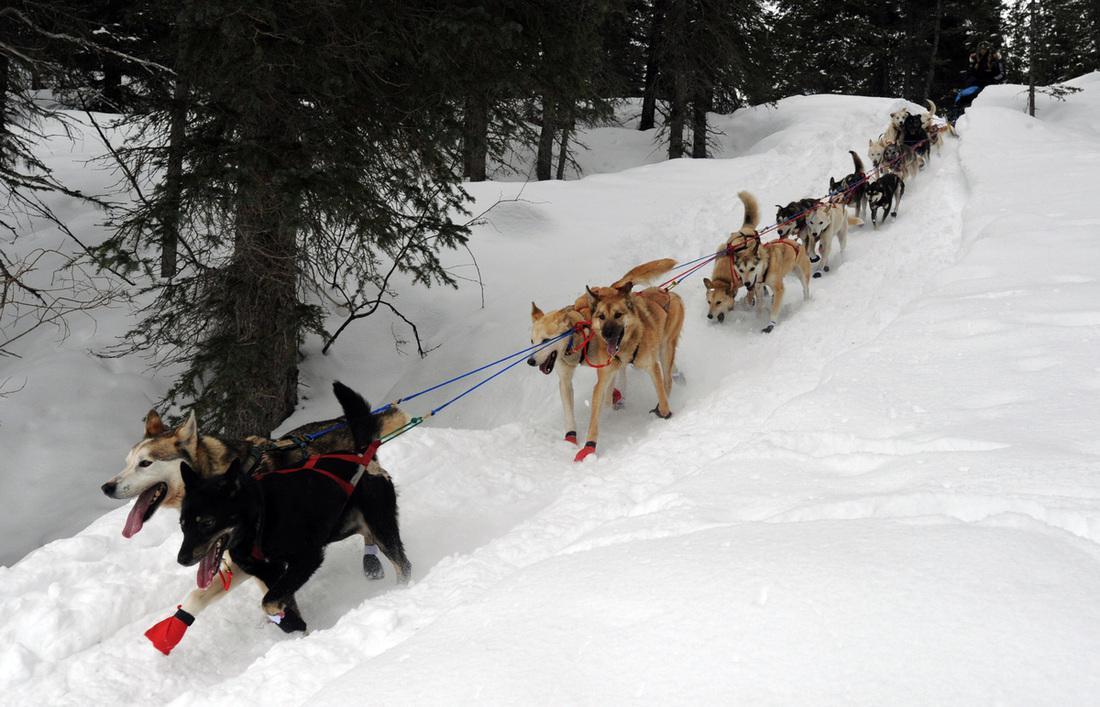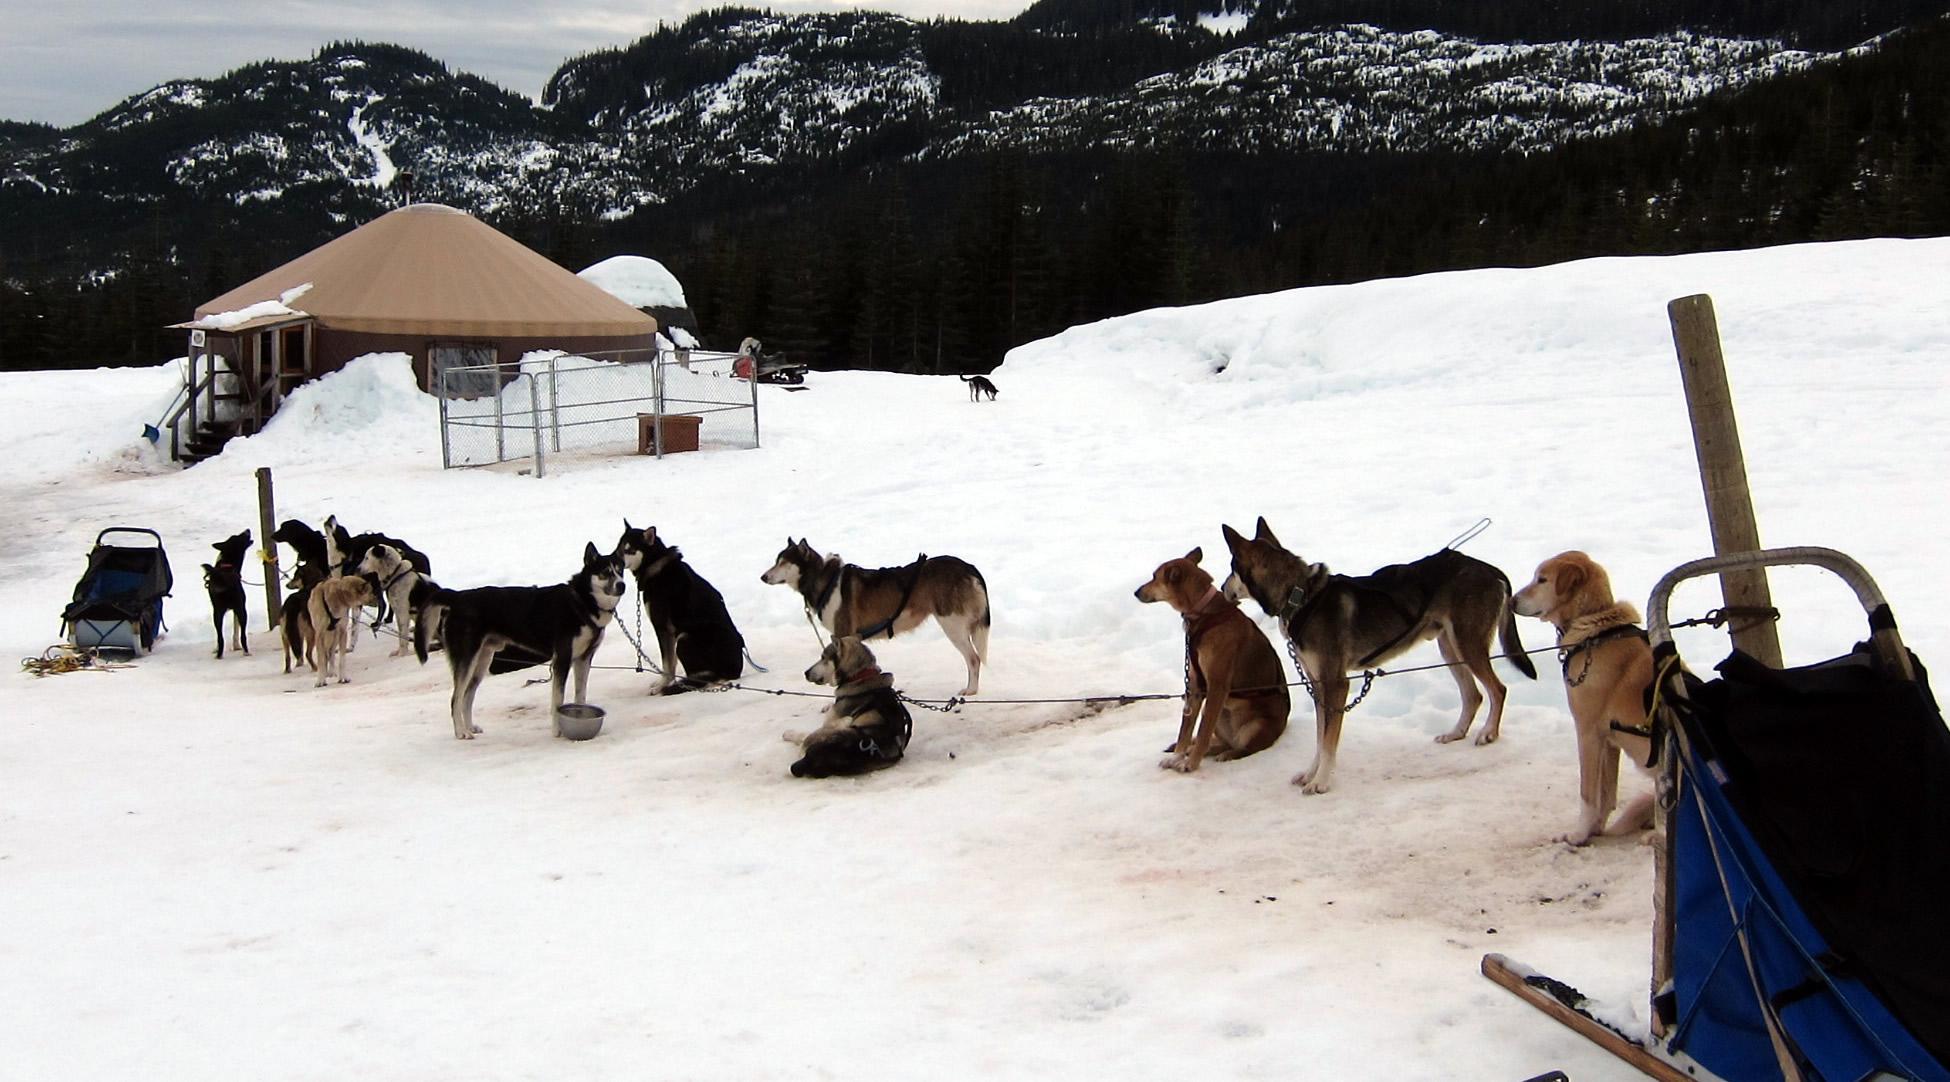The first image is the image on the left, the second image is the image on the right. Examine the images to the left and right. Is the description "Each image includes a sled dog team facing away from the camera toward a trail lined with trees." accurate? Answer yes or no. No. The first image is the image on the left, the second image is the image on the right. Examine the images to the left and right. Is the description "In one of the images, at least eight sled dogs are resting in the snow." accurate? Answer yes or no. Yes. 